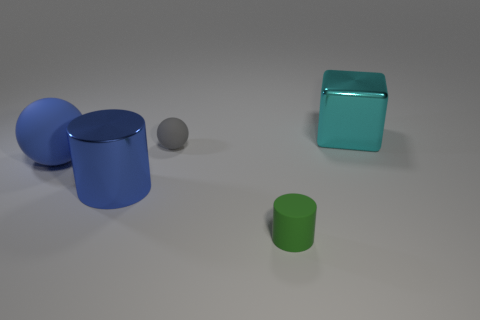Add 1 shiny cubes. How many objects exist? 6 Subtract all cubes. How many objects are left? 4 Add 2 big blue cylinders. How many big blue cylinders exist? 3 Subtract 0 blue blocks. How many objects are left? 5 Subtract all gray rubber spheres. Subtract all large gray metal things. How many objects are left? 4 Add 5 blue shiny objects. How many blue shiny objects are left? 6 